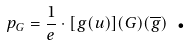<formula> <loc_0><loc_0><loc_500><loc_500>p _ { G } = \frac { 1 } { e } \cdot [ g ( u ) ] ( G ) ( \overline { g } ) \text { .}</formula> 